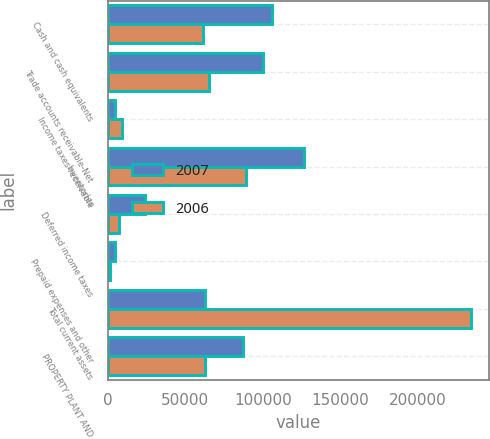Convert chart. <chart><loc_0><loc_0><loc_500><loc_500><stacked_bar_chart><ecel><fcel>Cash and cash equivalents<fcel>Trade accounts receivable-Net<fcel>Income taxes receivable<fcel>Inventories<fcel>Deferred income taxes<fcel>Prepaid expenses and other<fcel>Total current assets<fcel>PROPERTY PLANT AND<nl><fcel>2007<fcel>105946<fcel>100094<fcel>4472<fcel>126763<fcel>23923<fcel>4401<fcel>62851<fcel>87074<nl><fcel>2006<fcel>61217<fcel>65568<fcel>9366<fcel>89243<fcel>7390<fcel>1397<fcel>234181<fcel>62851<nl></chart> 